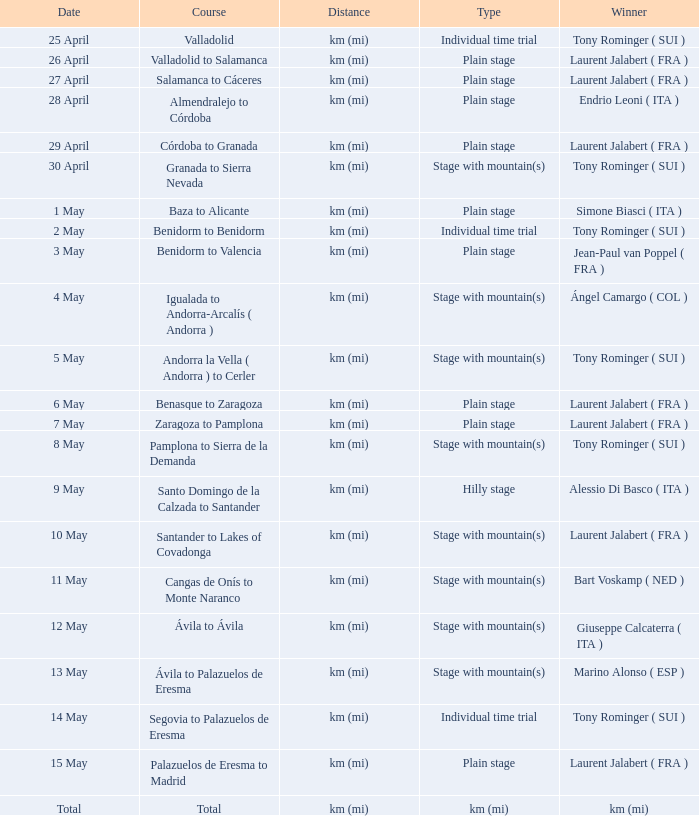What was the date with a winner of km (mi)? Total. 